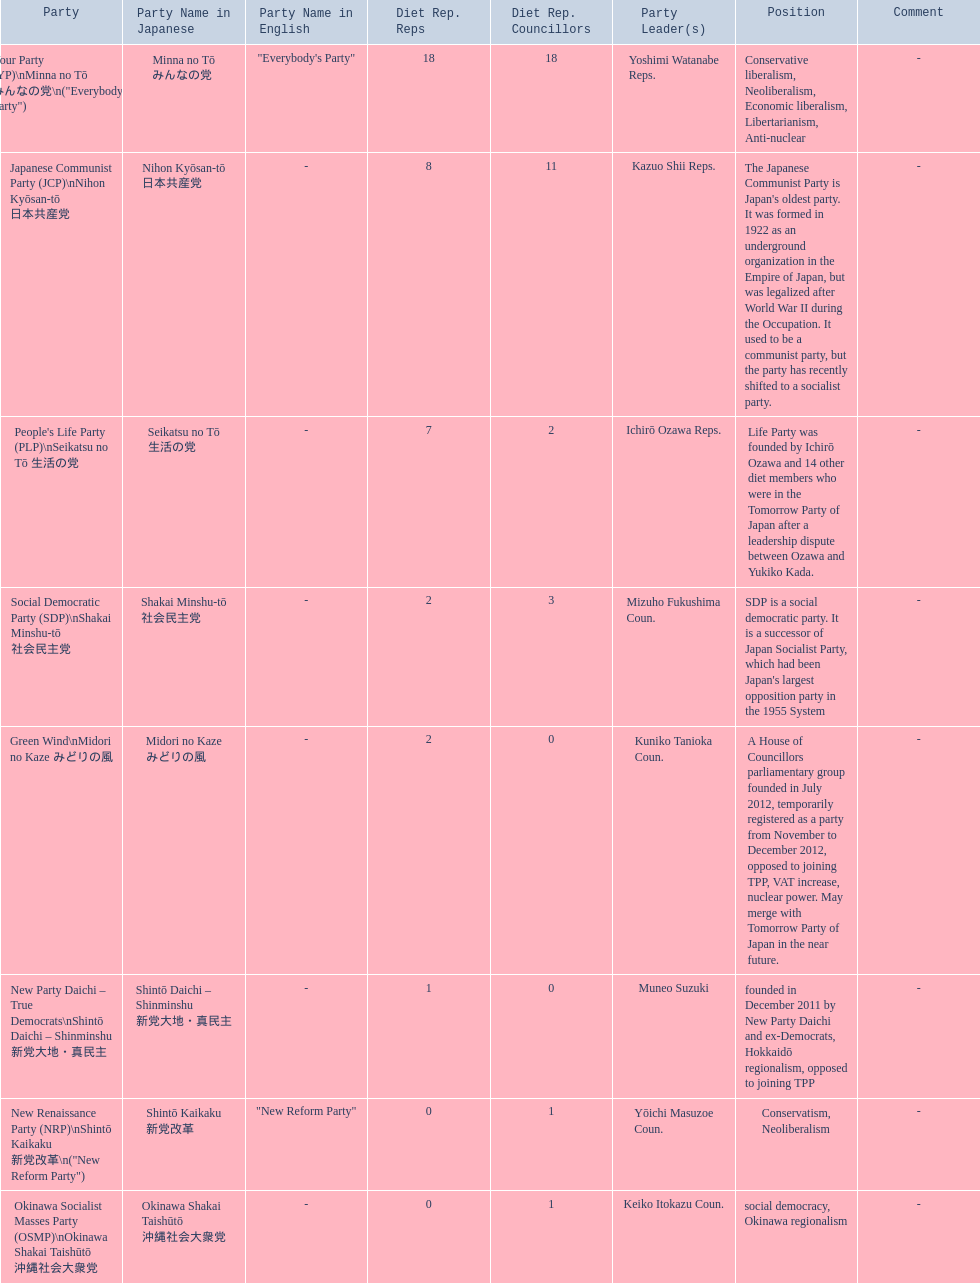What party is listed previous to the new renaissance party? New Party Daichi - True Democrats. 